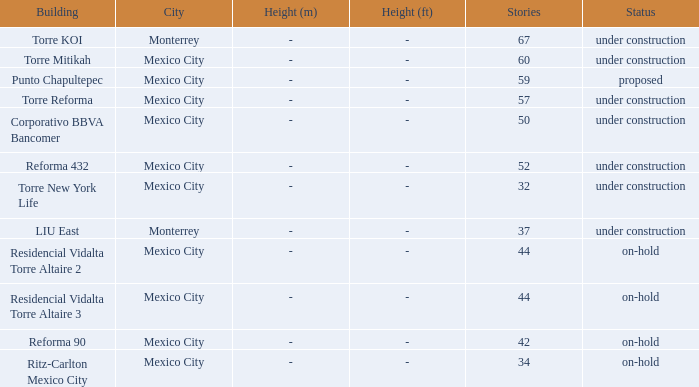How many floors does the torre reforma building have? 1.0. 